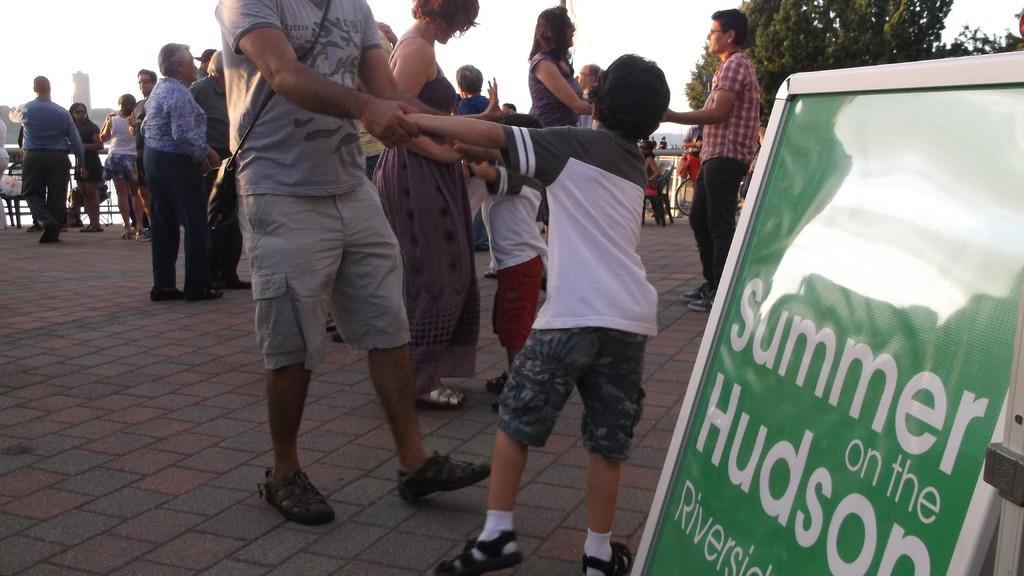How would you summarize this image in a sentence or two? In this image we can see persons standing on the floor, information board, bicycle, persons sitting on the chairs, sky and trees. 